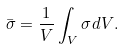<formula> <loc_0><loc_0><loc_500><loc_500>\bar { \sigma } = \frac { 1 } { V } \int _ { V } { \sigma d V } .</formula> 